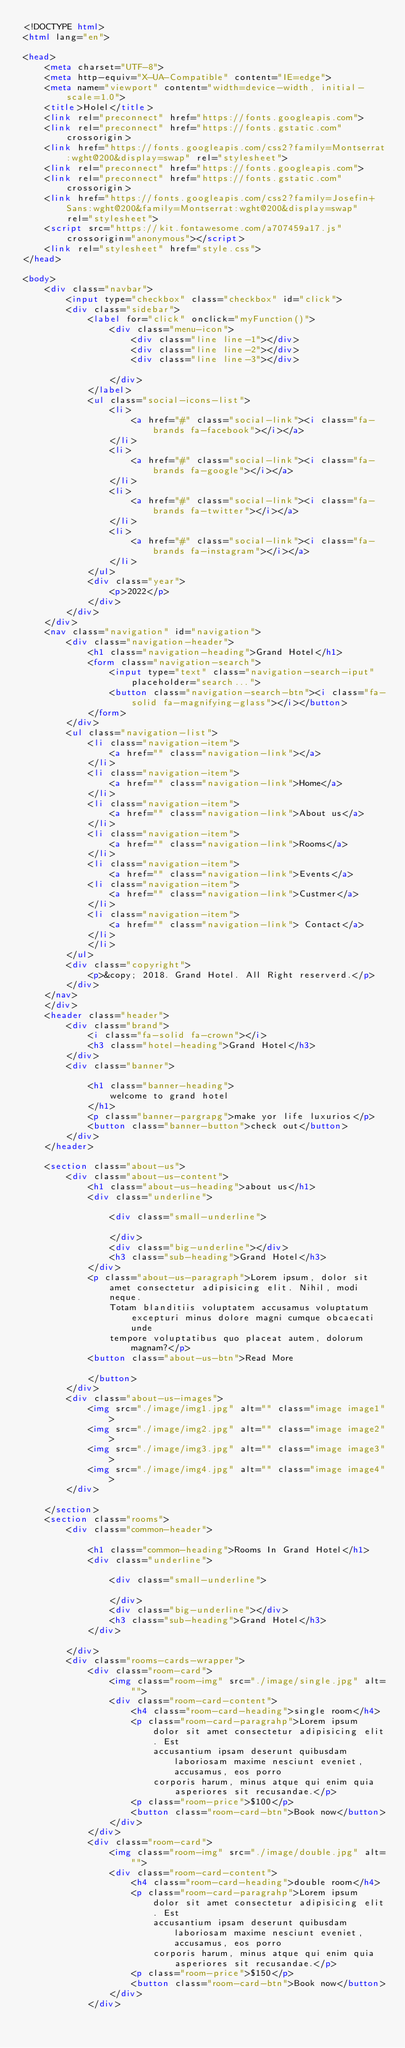Convert code to text. <code><loc_0><loc_0><loc_500><loc_500><_HTML_><!DOCTYPE html>
<html lang="en">

<head>
    <meta charset="UTF-8">
    <meta http-equiv="X-UA-Compatible" content="IE=edge">
    <meta name="viewport" content="width=device-width, initial-scale=1.0">
    <title>Holel</title>
    <link rel="preconnect" href="https://fonts.googleapis.com">
    <link rel="preconnect" href="https://fonts.gstatic.com" crossorigin>
    <link href="https://fonts.googleapis.com/css2?family=Montserrat:wght@200&display=swap" rel="stylesheet">
    <link rel="preconnect" href="https://fonts.googleapis.com">
    <link rel="preconnect" href="https://fonts.gstatic.com" crossorigin>
    <link href="https://fonts.googleapis.com/css2?family=Josefin+Sans:wght@200&family=Montserrat:wght@200&display=swap"
        rel="stylesheet">
    <script src="https://kit.fontawesome.com/a707459a17.js" crossorigin="anonymous"></script>
    <link rel="stylesheet" href="style.css">
</head>

<body>
    <div class="navbar">
        <input type="checkbox" class="checkbox" id="click">
        <div class="sidebar">
            <label for="click" onclick="myFunction()">
                <div class="menu-icon">
                    <div class="line line-1"></div>
                    <div class="line line-2"></div>
                    <div class="line line-3"></div>

                </div>
            </label>
            <ul class="social-icons-list">
                <li>
                    <a href="#" class="social-link"><i class="fa-brands fa-facebook"></i></a>
                </li>
                <li>
                    <a href="#" class="social-link"><i class="fa-brands fa-google"></i></a>
                </li>
                <li>
                    <a href="#" class="social-link"><i class="fa-brands fa-twitter"></i></a>
                </li>
                <li>
                    <a href="#" class="social-link"><i class="fa-brands fa-instagram"></i></a>
                </li>
            </ul>
            <div class="year">
                <p>2022</p>
            </div>
        </div>
    </div>
    <nav class="navigation" id="navigation">
        <div class="navigation-header">
            <h1 class="navigation-heading">Grand Hotel</h1>
            <form class="navigation-search">
                <input type="text" class="navigation-search-iput" placeholder="search...">
                <button class="navigation-search-btn"><i class="fa-solid fa-magnifying-glass"></i></button>
            </form>
        </div>
        <ul class="navigation-list">
            <li class="navigation-item">
                <a href="" class="navigation-link"></a>
            </li>
            <li class="navigation-item">
                <a href="" class="navigation-link">Home</a>
            </li>
            <li class="navigation-item">
                <a href="" class="navigation-link">About us</a>
            </li>
            <li class="navigation-item">
                <a href="" class="navigation-link">Rooms</a>
            </li>
            <li class="navigation-item">
                <a href="" class="navigation-link">Events</a>
            <li class="navigation-item">
                <a href="" class="navigation-link">Custmer</a>
            </li>
            <li class="navigation-item">
                <a href="" class="navigation-link"> Contact</a>
            </li>
            </li>
        </ul>
        <div class="copyright">
            <p>&copy; 2018. Grand Hotel. All Right reserverd.</p>
        </div>
    </nav>
    </div>
    <header class="header">
        <div class="brand">
            <i class="fa-solid fa-crown"></i>
            <h3 class="hotel-heading">Grand Hotel</h3>
        </div>
        <div class="banner">

            <h1 class="banner-heading">
                welcome to grand hotel
            </h1>
            <p class="banner-pargrapg">make yor life luxurios</p>
            <button class="banner-button">check out</button>
        </div>
    </header>

    <section class="about-us">
        <div class="about-us-content">
            <h1 class="about-us-heading">about us</h1>
            <div class="underline">

                <div class="small-underline">

                </div>
                <div class="big-underline"></div>
                <h3 class="sub-heading">Grand Hotel</h3>
            </div>
            <p class="about-us-paragraph">Lorem ipsum, dolor sit amet consectetur adipisicing elit. Nihil, modi neque.
                Totam blanditiis voluptatem accusamus voluptatum excepturi minus dolore magni cumque obcaecati unde
                tempore voluptatibus quo placeat autem, dolorum magnam?</p>
            <button class="about-us-btn">Read More

            </button>
        </div>
        <div class="about-us-images">
            <img src="./image/img1.jpg" alt="" class="image image1">
            <img src="./image/img2.jpg" alt="" class="image image2">
            <img src="./image/img3.jpg" alt="" class="image image3">
            <img src="./image/img4.jpg" alt="" class="image image4">
        </div>

    </section>
    <section class="rooms">
        <div class="common-header">

            <h1 class="common-heading">Rooms In Grand Hotel</h1>
            <div class="underline">

                <div class="small-underline">

                </div>
                <div class="big-underline"></div>
                <h3 class="sub-heading">Grand Hotel</h3>
            </div>

        </div>
        <div class="rooms-cards-wrapper">
            <div class="room-card">
                <img class="room-img" src="./image/single.jpg" alt="">
                <div class="room-card-content">
                    <h4 class="room-card-heading">single room</h4>
                    <p class="room-card-paragrahp">Lorem ipsum dolor sit amet consectetur adipisicing elit. Est
                        accusantium ipsam deserunt quibusdam laboriosam maxime nesciunt eveniet, accusamus, eos porro
                        corporis harum, minus atque qui enim quia asperiores sit recusandae.</p>
                    <p class="room-price">$100</p>
                    <button class="room-card-btn">Book now</button>
                </div>
            </div>
            <div class="room-card">
                <img class="room-img" src="./image/double.jpg" alt="">
                <div class="room-card-content">
                    <h4 class="room-card-heading">double room</h4>
                    <p class="room-card-paragrahp">Lorem ipsum dolor sit amet consectetur adipisicing elit. Est
                        accusantium ipsam deserunt quibusdam laboriosam maxime nesciunt eveniet, accusamus, eos porro
                        corporis harum, minus atque qui enim quia asperiores sit recusandae.</p>
                    <p class="room-price">$150</p>
                    <button class="room-card-btn">Book now</button>
                </div>
            </div></code> 